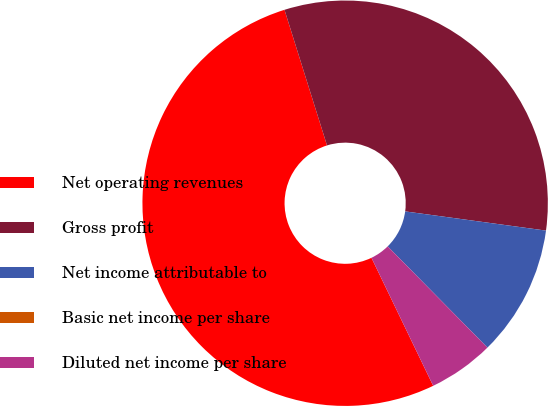Convert chart to OTSL. <chart><loc_0><loc_0><loc_500><loc_500><pie_chart><fcel>Net operating revenues<fcel>Gross profit<fcel>Net income attributable to<fcel>Basic net income per share<fcel>Diluted net income per share<nl><fcel>52.31%<fcel>31.99%<fcel>10.46%<fcel>0.0%<fcel>5.23%<nl></chart> 